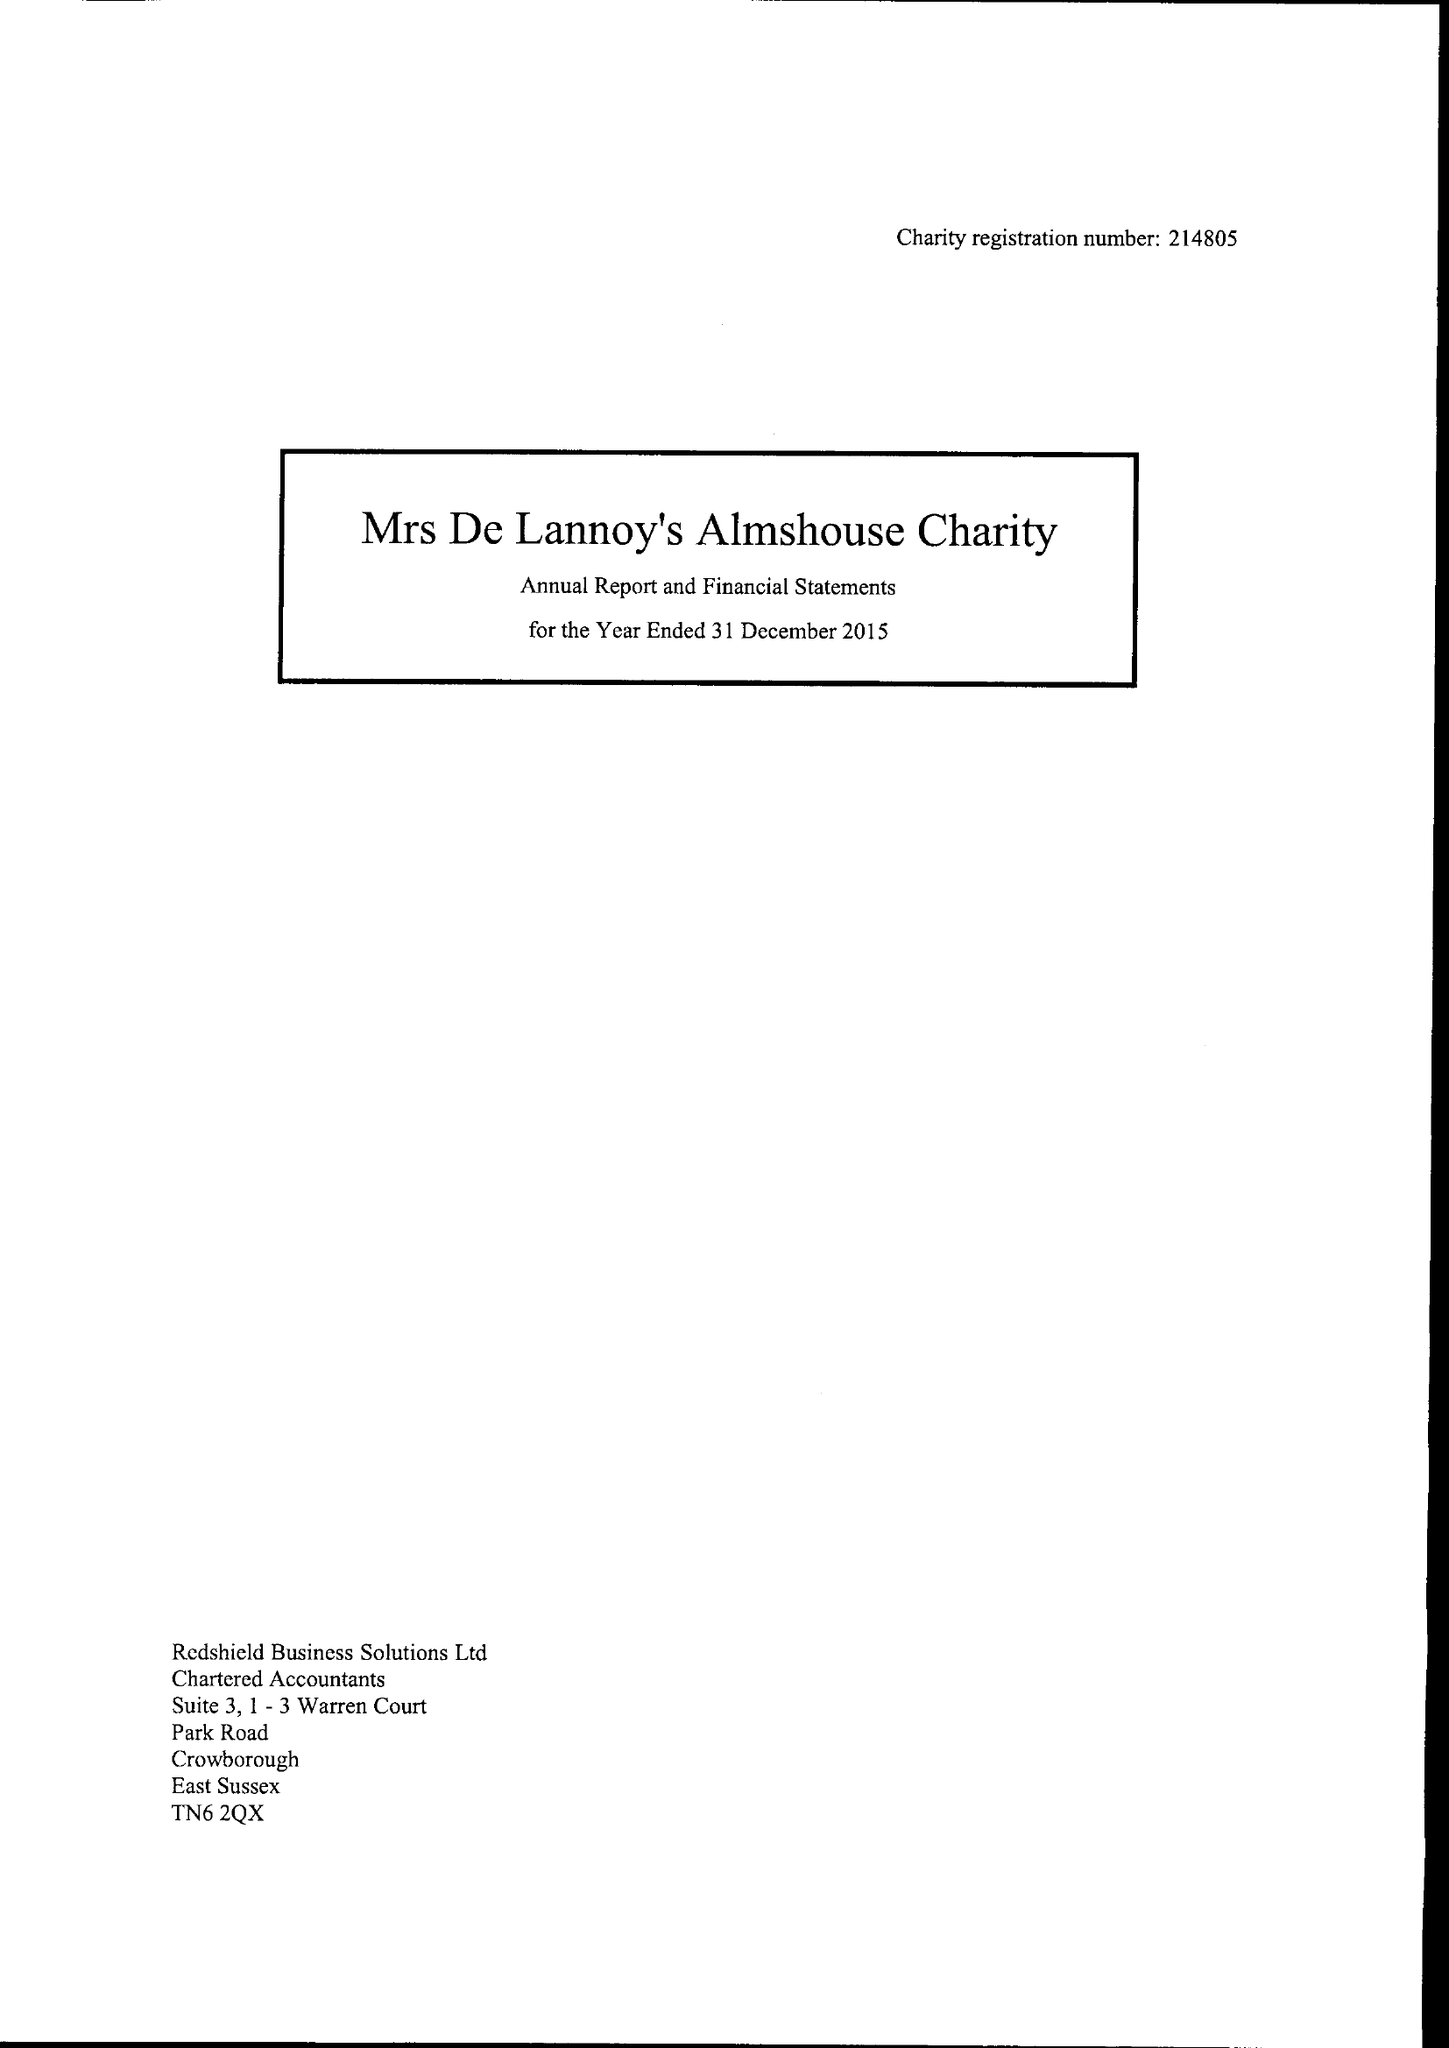What is the value for the address__postcode?
Answer the question using a single word or phrase. TN6 1SJ 